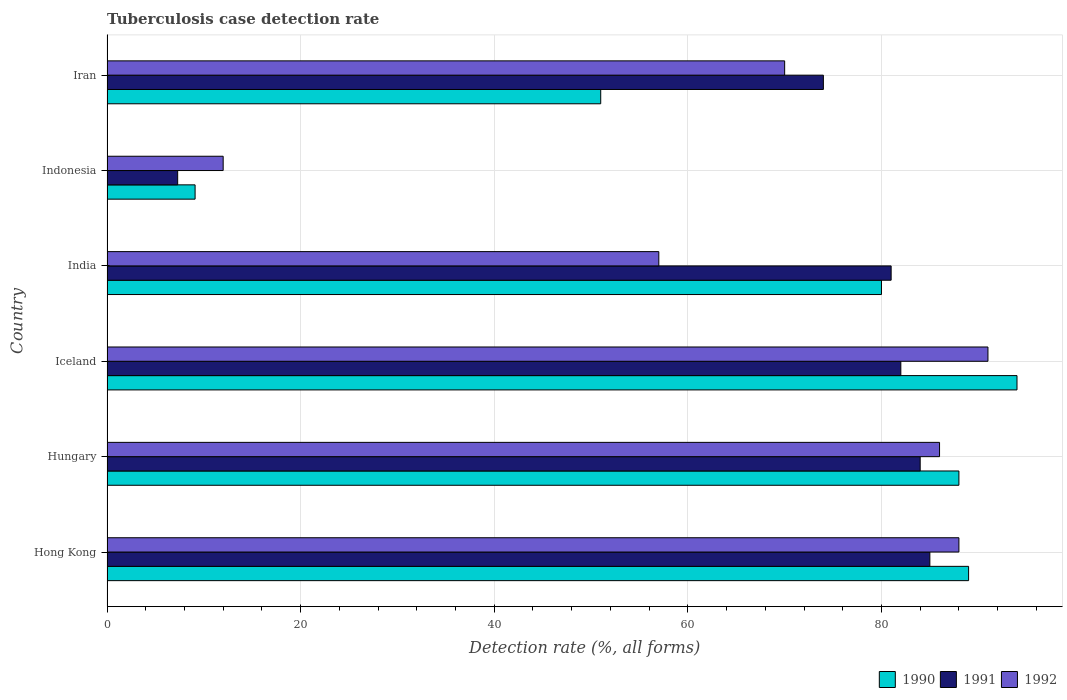How many groups of bars are there?
Provide a succinct answer. 6. Are the number of bars per tick equal to the number of legend labels?
Offer a very short reply. Yes. How many bars are there on the 5th tick from the bottom?
Make the answer very short. 3. What is the label of the 4th group of bars from the top?
Your response must be concise. Iceland. What is the tuberculosis case detection rate in in 1992 in Iceland?
Your response must be concise. 91. In which country was the tuberculosis case detection rate in in 1990 maximum?
Keep it short and to the point. Iceland. What is the total tuberculosis case detection rate in in 1990 in the graph?
Offer a terse response. 411.1. What is the difference between the tuberculosis case detection rate in in 1991 in Hungary and that in Indonesia?
Make the answer very short. 76.7. What is the difference between the tuberculosis case detection rate in in 1992 in Iceland and the tuberculosis case detection rate in in 1990 in Hungary?
Ensure brevity in your answer.  3. What is the average tuberculosis case detection rate in in 1990 per country?
Offer a terse response. 68.52. What is the difference between the tuberculosis case detection rate in in 1990 and tuberculosis case detection rate in in 1992 in Iceland?
Make the answer very short. 3. What is the ratio of the tuberculosis case detection rate in in 1992 in India to that in Indonesia?
Keep it short and to the point. 4.75. Is the tuberculosis case detection rate in in 1991 in Indonesia less than that in Iran?
Keep it short and to the point. Yes. What is the difference between the highest and the second highest tuberculosis case detection rate in in 1990?
Provide a short and direct response. 5. What is the difference between the highest and the lowest tuberculosis case detection rate in in 1990?
Your answer should be compact. 84.9. Is the sum of the tuberculosis case detection rate in in 1990 in Hungary and India greater than the maximum tuberculosis case detection rate in in 1992 across all countries?
Ensure brevity in your answer.  Yes. What does the 3rd bar from the bottom in India represents?
Provide a succinct answer. 1992. Is it the case that in every country, the sum of the tuberculosis case detection rate in in 1992 and tuberculosis case detection rate in in 1990 is greater than the tuberculosis case detection rate in in 1991?
Your response must be concise. Yes. Are all the bars in the graph horizontal?
Keep it short and to the point. Yes. What is the difference between two consecutive major ticks on the X-axis?
Your answer should be compact. 20. Are the values on the major ticks of X-axis written in scientific E-notation?
Your answer should be very brief. No. Does the graph contain any zero values?
Provide a succinct answer. No. What is the title of the graph?
Ensure brevity in your answer.  Tuberculosis case detection rate. Does "2002" appear as one of the legend labels in the graph?
Your answer should be compact. No. What is the label or title of the X-axis?
Keep it short and to the point. Detection rate (%, all forms). What is the Detection rate (%, all forms) of 1990 in Hong Kong?
Offer a very short reply. 89. What is the Detection rate (%, all forms) of 1991 in Hong Kong?
Your answer should be very brief. 85. What is the Detection rate (%, all forms) of 1992 in Hong Kong?
Your answer should be compact. 88. What is the Detection rate (%, all forms) in 1991 in Hungary?
Your answer should be very brief. 84. What is the Detection rate (%, all forms) of 1992 in Hungary?
Make the answer very short. 86. What is the Detection rate (%, all forms) of 1990 in Iceland?
Keep it short and to the point. 94. What is the Detection rate (%, all forms) in 1992 in Iceland?
Your answer should be very brief. 91. What is the Detection rate (%, all forms) of 1992 in India?
Your answer should be compact. 57. What is the Detection rate (%, all forms) in 1991 in Indonesia?
Provide a short and direct response. 7.3. What is the Detection rate (%, all forms) in 1991 in Iran?
Provide a short and direct response. 74. What is the Detection rate (%, all forms) in 1992 in Iran?
Your response must be concise. 70. Across all countries, what is the maximum Detection rate (%, all forms) of 1990?
Keep it short and to the point. 94. Across all countries, what is the maximum Detection rate (%, all forms) in 1992?
Ensure brevity in your answer.  91. Across all countries, what is the minimum Detection rate (%, all forms) of 1992?
Make the answer very short. 12. What is the total Detection rate (%, all forms) of 1990 in the graph?
Give a very brief answer. 411.1. What is the total Detection rate (%, all forms) of 1991 in the graph?
Offer a very short reply. 413.3. What is the total Detection rate (%, all forms) of 1992 in the graph?
Your answer should be compact. 404. What is the difference between the Detection rate (%, all forms) in 1990 in Hong Kong and that in Hungary?
Offer a very short reply. 1. What is the difference between the Detection rate (%, all forms) in 1991 in Hong Kong and that in Hungary?
Offer a terse response. 1. What is the difference between the Detection rate (%, all forms) in 1992 in Hong Kong and that in Hungary?
Your answer should be very brief. 2. What is the difference between the Detection rate (%, all forms) in 1992 in Hong Kong and that in Iceland?
Your response must be concise. -3. What is the difference between the Detection rate (%, all forms) in 1990 in Hong Kong and that in Indonesia?
Ensure brevity in your answer.  79.9. What is the difference between the Detection rate (%, all forms) of 1991 in Hong Kong and that in Indonesia?
Your response must be concise. 77.7. What is the difference between the Detection rate (%, all forms) of 1990 in Hong Kong and that in Iran?
Give a very brief answer. 38. What is the difference between the Detection rate (%, all forms) of 1992 in Hungary and that in Iceland?
Keep it short and to the point. -5. What is the difference between the Detection rate (%, all forms) in 1990 in Hungary and that in India?
Provide a short and direct response. 8. What is the difference between the Detection rate (%, all forms) of 1991 in Hungary and that in India?
Provide a succinct answer. 3. What is the difference between the Detection rate (%, all forms) of 1992 in Hungary and that in India?
Give a very brief answer. 29. What is the difference between the Detection rate (%, all forms) of 1990 in Hungary and that in Indonesia?
Give a very brief answer. 78.9. What is the difference between the Detection rate (%, all forms) in 1991 in Hungary and that in Indonesia?
Make the answer very short. 76.7. What is the difference between the Detection rate (%, all forms) of 1992 in Hungary and that in Iran?
Your answer should be very brief. 16. What is the difference between the Detection rate (%, all forms) in 1991 in Iceland and that in India?
Provide a short and direct response. 1. What is the difference between the Detection rate (%, all forms) of 1992 in Iceland and that in India?
Provide a short and direct response. 34. What is the difference between the Detection rate (%, all forms) of 1990 in Iceland and that in Indonesia?
Offer a terse response. 84.9. What is the difference between the Detection rate (%, all forms) in 1991 in Iceland and that in Indonesia?
Offer a terse response. 74.7. What is the difference between the Detection rate (%, all forms) of 1992 in Iceland and that in Indonesia?
Offer a very short reply. 79. What is the difference between the Detection rate (%, all forms) of 1990 in Iceland and that in Iran?
Provide a succinct answer. 43. What is the difference between the Detection rate (%, all forms) in 1990 in India and that in Indonesia?
Your response must be concise. 70.9. What is the difference between the Detection rate (%, all forms) of 1991 in India and that in Indonesia?
Make the answer very short. 73.7. What is the difference between the Detection rate (%, all forms) in 1991 in India and that in Iran?
Provide a short and direct response. 7. What is the difference between the Detection rate (%, all forms) of 1992 in India and that in Iran?
Provide a short and direct response. -13. What is the difference between the Detection rate (%, all forms) in 1990 in Indonesia and that in Iran?
Give a very brief answer. -41.9. What is the difference between the Detection rate (%, all forms) in 1991 in Indonesia and that in Iran?
Keep it short and to the point. -66.7. What is the difference between the Detection rate (%, all forms) in 1992 in Indonesia and that in Iran?
Your response must be concise. -58. What is the difference between the Detection rate (%, all forms) in 1990 in Hong Kong and the Detection rate (%, all forms) in 1992 in Hungary?
Give a very brief answer. 3. What is the difference between the Detection rate (%, all forms) of 1990 in Hong Kong and the Detection rate (%, all forms) of 1991 in India?
Ensure brevity in your answer.  8. What is the difference between the Detection rate (%, all forms) of 1990 in Hong Kong and the Detection rate (%, all forms) of 1991 in Indonesia?
Your answer should be compact. 81.7. What is the difference between the Detection rate (%, all forms) of 1990 in Hong Kong and the Detection rate (%, all forms) of 1992 in Indonesia?
Provide a succinct answer. 77. What is the difference between the Detection rate (%, all forms) in 1991 in Hong Kong and the Detection rate (%, all forms) in 1992 in Indonesia?
Offer a terse response. 73. What is the difference between the Detection rate (%, all forms) of 1990 in Hong Kong and the Detection rate (%, all forms) of 1991 in Iran?
Offer a very short reply. 15. What is the difference between the Detection rate (%, all forms) of 1990 in Hungary and the Detection rate (%, all forms) of 1992 in Iceland?
Ensure brevity in your answer.  -3. What is the difference between the Detection rate (%, all forms) in 1990 in Hungary and the Detection rate (%, all forms) in 1991 in India?
Your answer should be compact. 7. What is the difference between the Detection rate (%, all forms) in 1990 in Hungary and the Detection rate (%, all forms) in 1992 in India?
Keep it short and to the point. 31. What is the difference between the Detection rate (%, all forms) in 1991 in Hungary and the Detection rate (%, all forms) in 1992 in India?
Make the answer very short. 27. What is the difference between the Detection rate (%, all forms) of 1990 in Hungary and the Detection rate (%, all forms) of 1991 in Indonesia?
Your answer should be very brief. 80.7. What is the difference between the Detection rate (%, all forms) of 1990 in Hungary and the Detection rate (%, all forms) of 1991 in Iran?
Offer a very short reply. 14. What is the difference between the Detection rate (%, all forms) of 1990 in Hungary and the Detection rate (%, all forms) of 1992 in Iran?
Your response must be concise. 18. What is the difference between the Detection rate (%, all forms) of 1991 in Hungary and the Detection rate (%, all forms) of 1992 in Iran?
Your answer should be very brief. 14. What is the difference between the Detection rate (%, all forms) of 1990 in Iceland and the Detection rate (%, all forms) of 1991 in India?
Give a very brief answer. 13. What is the difference between the Detection rate (%, all forms) of 1990 in Iceland and the Detection rate (%, all forms) of 1992 in India?
Make the answer very short. 37. What is the difference between the Detection rate (%, all forms) in 1990 in Iceland and the Detection rate (%, all forms) in 1991 in Indonesia?
Provide a succinct answer. 86.7. What is the difference between the Detection rate (%, all forms) in 1991 in Iceland and the Detection rate (%, all forms) in 1992 in Indonesia?
Your answer should be very brief. 70. What is the difference between the Detection rate (%, all forms) in 1990 in Iceland and the Detection rate (%, all forms) in 1992 in Iran?
Offer a terse response. 24. What is the difference between the Detection rate (%, all forms) of 1990 in India and the Detection rate (%, all forms) of 1991 in Indonesia?
Provide a short and direct response. 72.7. What is the difference between the Detection rate (%, all forms) of 1990 in India and the Detection rate (%, all forms) of 1991 in Iran?
Keep it short and to the point. 6. What is the difference between the Detection rate (%, all forms) of 1991 in India and the Detection rate (%, all forms) of 1992 in Iran?
Give a very brief answer. 11. What is the difference between the Detection rate (%, all forms) of 1990 in Indonesia and the Detection rate (%, all forms) of 1991 in Iran?
Provide a succinct answer. -64.9. What is the difference between the Detection rate (%, all forms) of 1990 in Indonesia and the Detection rate (%, all forms) of 1992 in Iran?
Your answer should be compact. -60.9. What is the difference between the Detection rate (%, all forms) of 1991 in Indonesia and the Detection rate (%, all forms) of 1992 in Iran?
Keep it short and to the point. -62.7. What is the average Detection rate (%, all forms) in 1990 per country?
Offer a very short reply. 68.52. What is the average Detection rate (%, all forms) of 1991 per country?
Your answer should be very brief. 68.88. What is the average Detection rate (%, all forms) in 1992 per country?
Keep it short and to the point. 67.33. What is the difference between the Detection rate (%, all forms) of 1990 and Detection rate (%, all forms) of 1991 in Hong Kong?
Offer a terse response. 4. What is the difference between the Detection rate (%, all forms) of 1990 and Detection rate (%, all forms) of 1992 in Hong Kong?
Keep it short and to the point. 1. What is the difference between the Detection rate (%, all forms) of 1991 and Detection rate (%, all forms) of 1992 in Hungary?
Ensure brevity in your answer.  -2. What is the difference between the Detection rate (%, all forms) in 1990 and Detection rate (%, all forms) in 1991 in Iceland?
Your answer should be compact. 12. What is the difference between the Detection rate (%, all forms) in 1990 and Detection rate (%, all forms) in 1992 in Iceland?
Your response must be concise. 3. What is the difference between the Detection rate (%, all forms) in 1991 and Detection rate (%, all forms) in 1992 in Iceland?
Provide a succinct answer. -9. What is the difference between the Detection rate (%, all forms) of 1990 and Detection rate (%, all forms) of 1991 in India?
Your answer should be very brief. -1. What is the difference between the Detection rate (%, all forms) of 1990 and Detection rate (%, all forms) of 1992 in Indonesia?
Ensure brevity in your answer.  -2.9. What is the difference between the Detection rate (%, all forms) of 1991 and Detection rate (%, all forms) of 1992 in Indonesia?
Ensure brevity in your answer.  -4.7. What is the difference between the Detection rate (%, all forms) of 1990 and Detection rate (%, all forms) of 1991 in Iran?
Your answer should be very brief. -23. What is the difference between the Detection rate (%, all forms) in 1991 and Detection rate (%, all forms) in 1992 in Iran?
Your answer should be compact. 4. What is the ratio of the Detection rate (%, all forms) of 1990 in Hong Kong to that in Hungary?
Offer a very short reply. 1.01. What is the ratio of the Detection rate (%, all forms) of 1991 in Hong Kong to that in Hungary?
Your response must be concise. 1.01. What is the ratio of the Detection rate (%, all forms) of 1992 in Hong Kong to that in Hungary?
Your answer should be very brief. 1.02. What is the ratio of the Detection rate (%, all forms) of 1990 in Hong Kong to that in Iceland?
Make the answer very short. 0.95. What is the ratio of the Detection rate (%, all forms) in 1991 in Hong Kong to that in Iceland?
Offer a very short reply. 1.04. What is the ratio of the Detection rate (%, all forms) in 1992 in Hong Kong to that in Iceland?
Your answer should be very brief. 0.97. What is the ratio of the Detection rate (%, all forms) of 1990 in Hong Kong to that in India?
Your answer should be very brief. 1.11. What is the ratio of the Detection rate (%, all forms) in 1991 in Hong Kong to that in India?
Offer a terse response. 1.05. What is the ratio of the Detection rate (%, all forms) of 1992 in Hong Kong to that in India?
Keep it short and to the point. 1.54. What is the ratio of the Detection rate (%, all forms) of 1990 in Hong Kong to that in Indonesia?
Offer a very short reply. 9.78. What is the ratio of the Detection rate (%, all forms) in 1991 in Hong Kong to that in Indonesia?
Make the answer very short. 11.64. What is the ratio of the Detection rate (%, all forms) in 1992 in Hong Kong to that in Indonesia?
Your answer should be very brief. 7.33. What is the ratio of the Detection rate (%, all forms) in 1990 in Hong Kong to that in Iran?
Provide a short and direct response. 1.75. What is the ratio of the Detection rate (%, all forms) in 1991 in Hong Kong to that in Iran?
Ensure brevity in your answer.  1.15. What is the ratio of the Detection rate (%, all forms) of 1992 in Hong Kong to that in Iran?
Your answer should be very brief. 1.26. What is the ratio of the Detection rate (%, all forms) in 1990 in Hungary to that in Iceland?
Make the answer very short. 0.94. What is the ratio of the Detection rate (%, all forms) of 1991 in Hungary to that in Iceland?
Offer a terse response. 1.02. What is the ratio of the Detection rate (%, all forms) of 1992 in Hungary to that in Iceland?
Your response must be concise. 0.95. What is the ratio of the Detection rate (%, all forms) in 1991 in Hungary to that in India?
Ensure brevity in your answer.  1.04. What is the ratio of the Detection rate (%, all forms) in 1992 in Hungary to that in India?
Provide a short and direct response. 1.51. What is the ratio of the Detection rate (%, all forms) of 1990 in Hungary to that in Indonesia?
Keep it short and to the point. 9.67. What is the ratio of the Detection rate (%, all forms) in 1991 in Hungary to that in Indonesia?
Provide a short and direct response. 11.51. What is the ratio of the Detection rate (%, all forms) of 1992 in Hungary to that in Indonesia?
Make the answer very short. 7.17. What is the ratio of the Detection rate (%, all forms) in 1990 in Hungary to that in Iran?
Offer a very short reply. 1.73. What is the ratio of the Detection rate (%, all forms) in 1991 in Hungary to that in Iran?
Keep it short and to the point. 1.14. What is the ratio of the Detection rate (%, all forms) of 1992 in Hungary to that in Iran?
Make the answer very short. 1.23. What is the ratio of the Detection rate (%, all forms) in 1990 in Iceland to that in India?
Your answer should be compact. 1.18. What is the ratio of the Detection rate (%, all forms) of 1991 in Iceland to that in India?
Provide a succinct answer. 1.01. What is the ratio of the Detection rate (%, all forms) of 1992 in Iceland to that in India?
Ensure brevity in your answer.  1.6. What is the ratio of the Detection rate (%, all forms) of 1990 in Iceland to that in Indonesia?
Keep it short and to the point. 10.33. What is the ratio of the Detection rate (%, all forms) of 1991 in Iceland to that in Indonesia?
Ensure brevity in your answer.  11.23. What is the ratio of the Detection rate (%, all forms) in 1992 in Iceland to that in Indonesia?
Offer a terse response. 7.58. What is the ratio of the Detection rate (%, all forms) of 1990 in Iceland to that in Iran?
Your answer should be very brief. 1.84. What is the ratio of the Detection rate (%, all forms) of 1991 in Iceland to that in Iran?
Offer a very short reply. 1.11. What is the ratio of the Detection rate (%, all forms) in 1992 in Iceland to that in Iran?
Give a very brief answer. 1.3. What is the ratio of the Detection rate (%, all forms) in 1990 in India to that in Indonesia?
Provide a succinct answer. 8.79. What is the ratio of the Detection rate (%, all forms) of 1991 in India to that in Indonesia?
Your answer should be compact. 11.1. What is the ratio of the Detection rate (%, all forms) of 1992 in India to that in Indonesia?
Offer a very short reply. 4.75. What is the ratio of the Detection rate (%, all forms) of 1990 in India to that in Iran?
Your answer should be compact. 1.57. What is the ratio of the Detection rate (%, all forms) of 1991 in India to that in Iran?
Provide a succinct answer. 1.09. What is the ratio of the Detection rate (%, all forms) in 1992 in India to that in Iran?
Provide a succinct answer. 0.81. What is the ratio of the Detection rate (%, all forms) in 1990 in Indonesia to that in Iran?
Offer a terse response. 0.18. What is the ratio of the Detection rate (%, all forms) of 1991 in Indonesia to that in Iran?
Give a very brief answer. 0.1. What is the ratio of the Detection rate (%, all forms) in 1992 in Indonesia to that in Iran?
Keep it short and to the point. 0.17. What is the difference between the highest and the lowest Detection rate (%, all forms) in 1990?
Your answer should be compact. 84.9. What is the difference between the highest and the lowest Detection rate (%, all forms) in 1991?
Provide a succinct answer. 77.7. What is the difference between the highest and the lowest Detection rate (%, all forms) of 1992?
Provide a short and direct response. 79. 